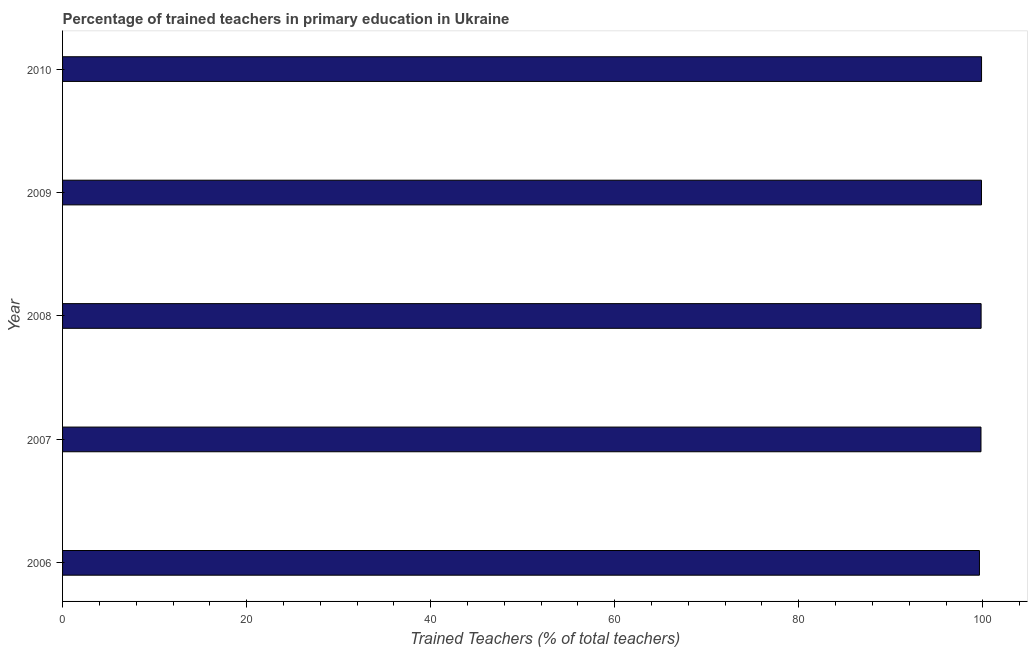Does the graph contain any zero values?
Keep it short and to the point. No. What is the title of the graph?
Offer a very short reply. Percentage of trained teachers in primary education in Ukraine. What is the label or title of the X-axis?
Provide a succinct answer. Trained Teachers (% of total teachers). What is the label or title of the Y-axis?
Offer a very short reply. Year. What is the percentage of trained teachers in 2006?
Your answer should be very brief. 99.63. Across all years, what is the maximum percentage of trained teachers?
Provide a short and direct response. 99.86. Across all years, what is the minimum percentage of trained teachers?
Your answer should be very brief. 99.63. What is the sum of the percentage of trained teachers?
Your response must be concise. 498.97. What is the difference between the percentage of trained teachers in 2006 and 2010?
Give a very brief answer. -0.23. What is the average percentage of trained teachers per year?
Your answer should be very brief. 99.79. What is the median percentage of trained teachers?
Your response must be concise. 99.82. Is the difference between the percentage of trained teachers in 2006 and 2008 greater than the difference between any two years?
Your answer should be very brief. No. What is the difference between the highest and the second highest percentage of trained teachers?
Give a very brief answer. 0.01. What is the difference between the highest and the lowest percentage of trained teachers?
Keep it short and to the point. 0.23. In how many years, is the percentage of trained teachers greater than the average percentage of trained teachers taken over all years?
Your answer should be compact. 4. How many bars are there?
Offer a very short reply. 5. Are all the bars in the graph horizontal?
Offer a very short reply. Yes. What is the Trained Teachers (% of total teachers) in 2006?
Keep it short and to the point. 99.63. What is the Trained Teachers (% of total teachers) in 2007?
Make the answer very short. 99.8. What is the Trained Teachers (% of total teachers) in 2008?
Ensure brevity in your answer.  99.82. What is the Trained Teachers (% of total teachers) of 2009?
Your answer should be very brief. 99.86. What is the Trained Teachers (% of total teachers) in 2010?
Offer a very short reply. 99.86. What is the difference between the Trained Teachers (% of total teachers) in 2006 and 2007?
Your answer should be very brief. -0.17. What is the difference between the Trained Teachers (% of total teachers) in 2006 and 2008?
Give a very brief answer. -0.18. What is the difference between the Trained Teachers (% of total teachers) in 2006 and 2009?
Provide a short and direct response. -0.22. What is the difference between the Trained Teachers (% of total teachers) in 2006 and 2010?
Offer a terse response. -0.23. What is the difference between the Trained Teachers (% of total teachers) in 2007 and 2008?
Provide a succinct answer. -0.01. What is the difference between the Trained Teachers (% of total teachers) in 2007 and 2009?
Provide a succinct answer. -0.05. What is the difference between the Trained Teachers (% of total teachers) in 2007 and 2010?
Provide a short and direct response. -0.06. What is the difference between the Trained Teachers (% of total teachers) in 2008 and 2009?
Provide a short and direct response. -0.04. What is the difference between the Trained Teachers (% of total teachers) in 2008 and 2010?
Provide a succinct answer. -0.05. What is the difference between the Trained Teachers (% of total teachers) in 2009 and 2010?
Your answer should be very brief. -0.01. What is the ratio of the Trained Teachers (% of total teachers) in 2006 to that in 2008?
Make the answer very short. 1. What is the ratio of the Trained Teachers (% of total teachers) in 2006 to that in 2009?
Your response must be concise. 1. What is the ratio of the Trained Teachers (% of total teachers) in 2007 to that in 2010?
Make the answer very short. 1. What is the ratio of the Trained Teachers (% of total teachers) in 2008 to that in 2009?
Your answer should be compact. 1. 